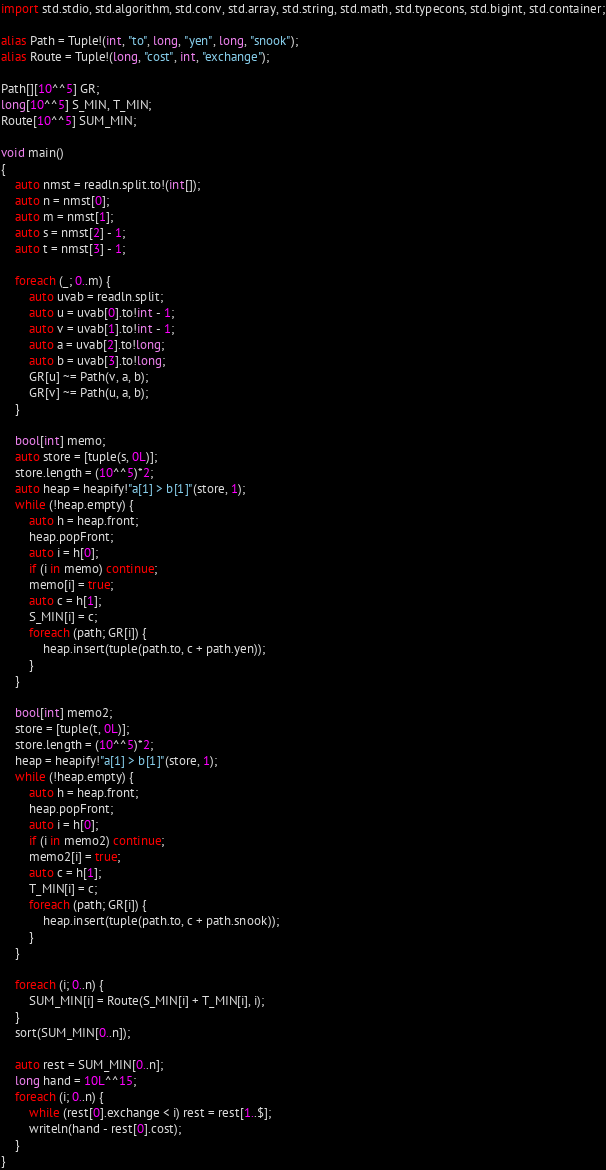Convert code to text. <code><loc_0><loc_0><loc_500><loc_500><_D_>import std.stdio, std.algorithm, std.conv, std.array, std.string, std.math, std.typecons, std.bigint, std.container;

alias Path = Tuple!(int, "to", long, "yen", long, "snook");
alias Route = Tuple!(long, "cost", int, "exchange");

Path[][10^^5] GR;
long[10^^5] S_MIN, T_MIN;
Route[10^^5] SUM_MIN;

void main()
{
    auto nmst = readln.split.to!(int[]);
    auto n = nmst[0];
    auto m = nmst[1];
    auto s = nmst[2] - 1;
    auto t = nmst[3] - 1;

    foreach (_; 0..m) {
        auto uvab = readln.split;
        auto u = uvab[0].to!int - 1;
        auto v = uvab[1].to!int - 1;
        auto a = uvab[2].to!long;
        auto b = uvab[3].to!long;
        GR[u] ~= Path(v, a, b);
        GR[v] ~= Path(u, a, b);
    }

    bool[int] memo;
    auto store = [tuple(s, 0L)];
    store.length = (10^^5)*2;
    auto heap = heapify!"a[1] > b[1]"(store, 1);
    while (!heap.empty) {
        auto h = heap.front;
        heap.popFront;
        auto i = h[0];
        if (i in memo) continue;
        memo[i] = true;
        auto c = h[1];
        S_MIN[i] = c;
        foreach (path; GR[i]) {
            heap.insert(tuple(path.to, c + path.yen));
        }
    }

    bool[int] memo2;
    store = [tuple(t, 0L)];
    store.length = (10^^5)*2;
    heap = heapify!"a[1] > b[1]"(store, 1);
    while (!heap.empty) {
        auto h = heap.front;
        heap.popFront;
        auto i = h[0];
        if (i in memo2) continue;
        memo2[i] = true;
        auto c = h[1];
        T_MIN[i] = c;
        foreach (path; GR[i]) {
            heap.insert(tuple(path.to, c + path.snook));
        }
    }

    foreach (i; 0..n) {
        SUM_MIN[i] = Route(S_MIN[i] + T_MIN[i], i);
    }
    sort(SUM_MIN[0..n]);

    auto rest = SUM_MIN[0..n];
    long hand = 10L^^15;
    foreach (i; 0..n) {
        while (rest[0].exchange < i) rest = rest[1..$];
        writeln(hand - rest[0].cost);
    }
}</code> 